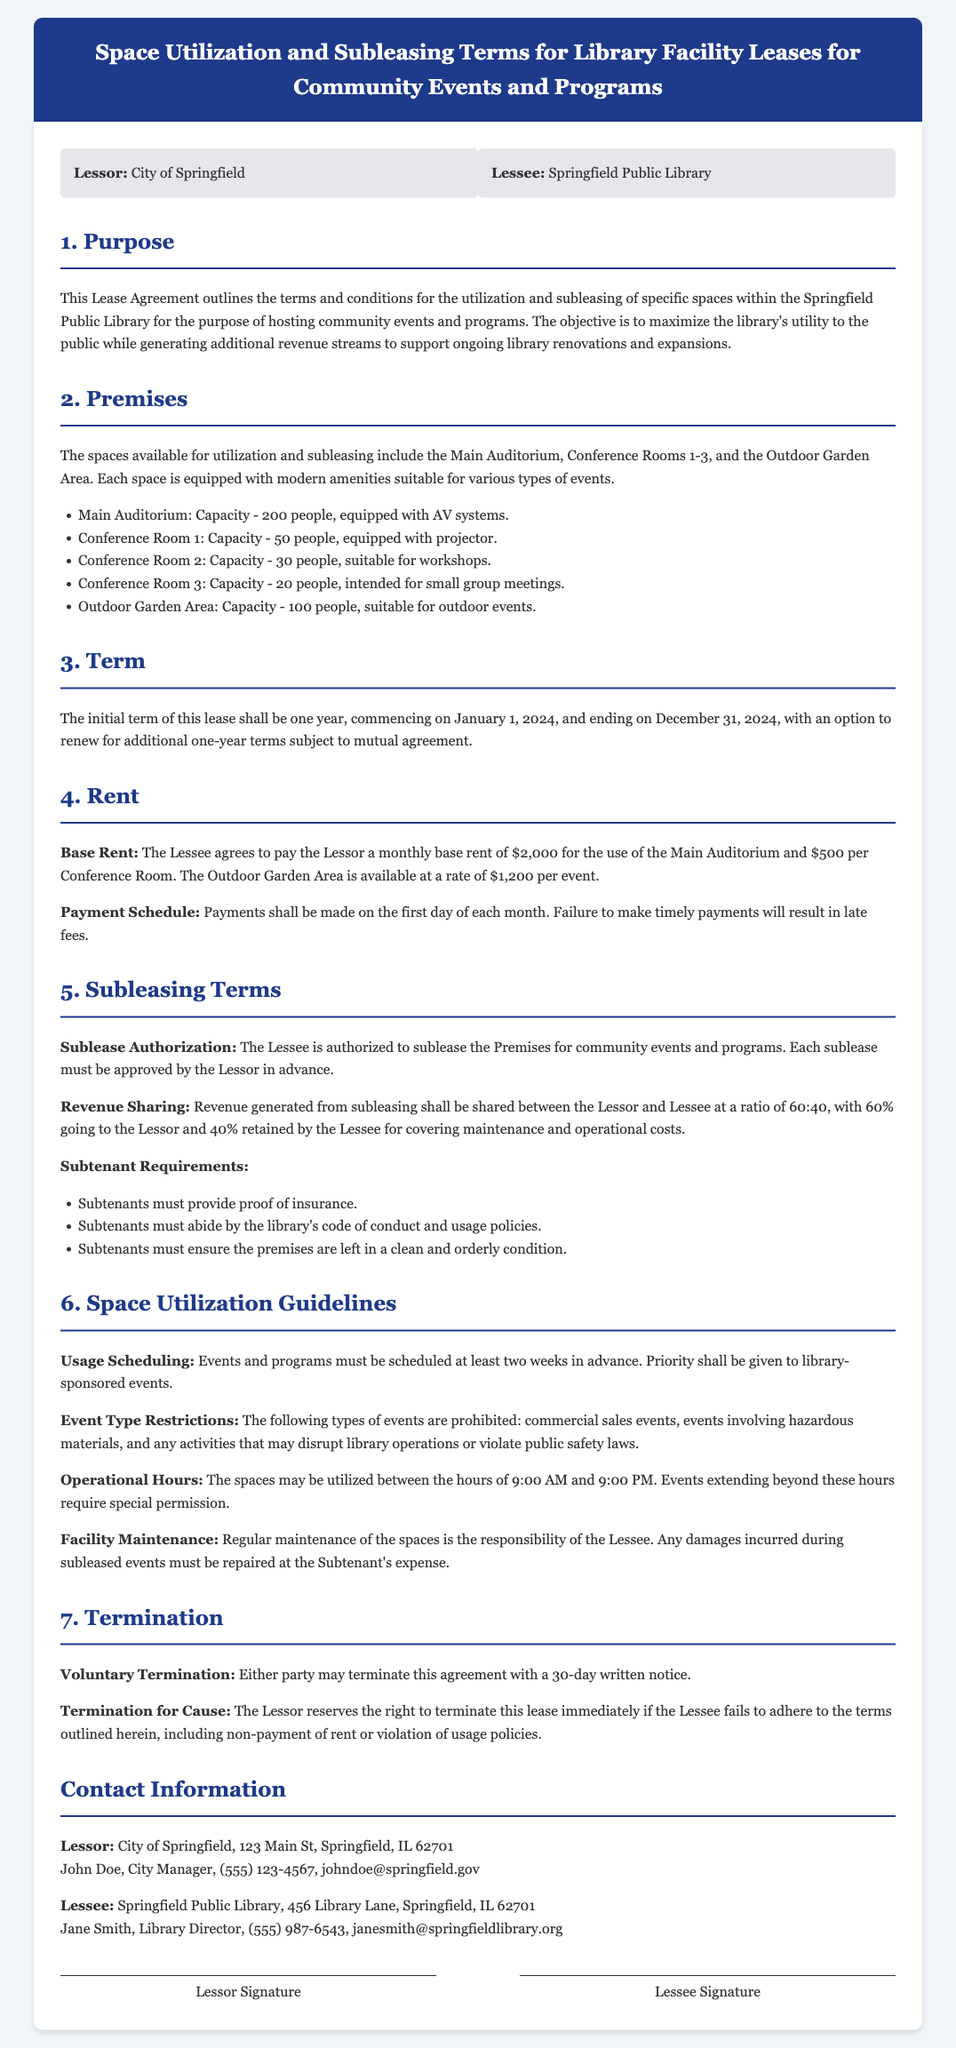What is the capacity of the Main Auditorium? The capacity of the Main Auditorium is specified in the section about the premises in the document.
Answer: 200 people What is the monthly base rent for Conference Room 1? The monthly base rent for Conference Room 1 is outlined in the rent section of the document.
Answer: $500 Who is the Lessee in this agreement? The Lessee is identified at the beginning of the document under the parties section.
Answer: Springfield Public Library What is the revenue sharing ratio for subleasing? The revenue sharing ratio for subleasing is detailed in the subleasing terms section.
Answer: 60:40 What is the initial term of the lease? The initial term of the lease is stated in the term section of the document.
Answer: One year Are commercial sales events allowed? The event type restrictions section specifies the types of events prohibited in the document.
Answer: No What is the contact title of the Lessor's representative? The contact title can be found in the contact information section of the document.
Answer: City Manager What must subtenants provide before subleasing? Subtenant requirements detail what is necessary for subtenants, found in the subleasing terms section.
Answer: Proof of insurance What is the operational hour limit for events? The operational hours for utilization and events are mentioned in the space utilization guidelines portion of the document.
Answer: 9:00 AM to 9:00 PM 